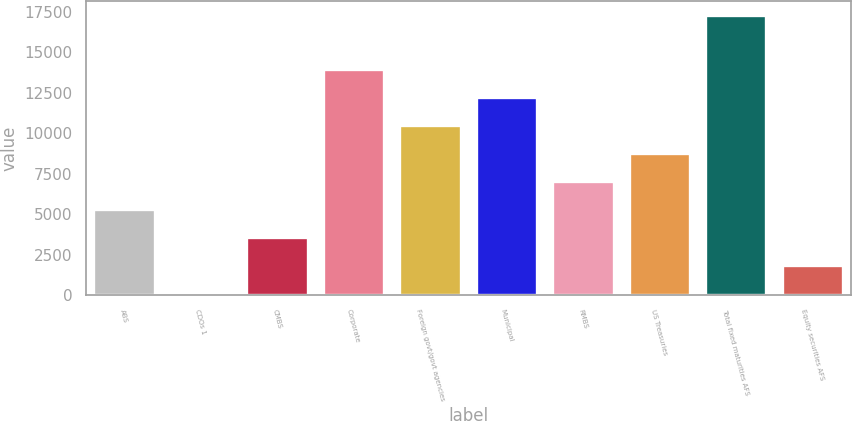Convert chart. <chart><loc_0><loc_0><loc_500><loc_500><bar_chart><fcel>ABS<fcel>CDOs 1<fcel>CMBS<fcel>Corporate<fcel>Foreign govt/govt agencies<fcel>Municipal<fcel>RMBS<fcel>US Treasuries<fcel>Total fixed maturities AFS<fcel>Equity securities AFS<nl><fcel>5334.9<fcel>135<fcel>3601.6<fcel>14001.4<fcel>10534.8<fcel>12268.1<fcel>7068.2<fcel>8801.5<fcel>17280<fcel>1868.3<nl></chart> 